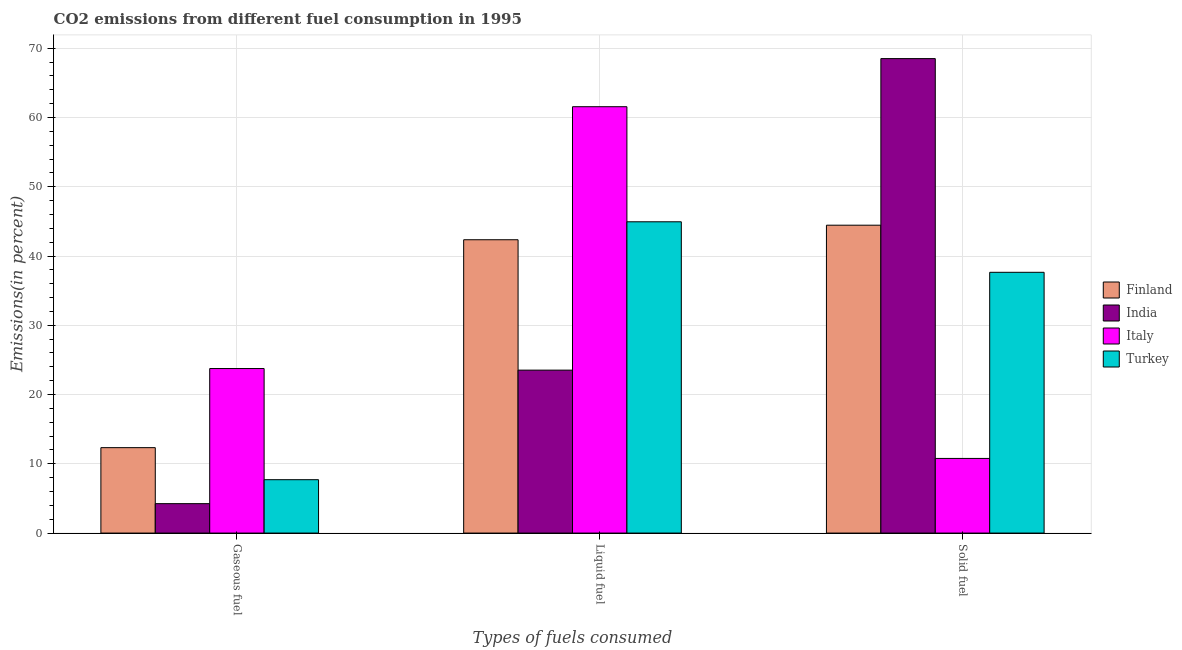How many different coloured bars are there?
Give a very brief answer. 4. How many groups of bars are there?
Your answer should be compact. 3. Are the number of bars on each tick of the X-axis equal?
Provide a succinct answer. Yes. How many bars are there on the 1st tick from the left?
Your answer should be very brief. 4. How many bars are there on the 3rd tick from the right?
Your answer should be very brief. 4. What is the label of the 1st group of bars from the left?
Offer a terse response. Gaseous fuel. What is the percentage of solid fuel emission in India?
Make the answer very short. 68.51. Across all countries, what is the maximum percentage of solid fuel emission?
Make the answer very short. 68.51. Across all countries, what is the minimum percentage of gaseous fuel emission?
Provide a short and direct response. 4.25. In which country was the percentage of solid fuel emission maximum?
Your answer should be compact. India. In which country was the percentage of liquid fuel emission minimum?
Offer a terse response. India. What is the total percentage of solid fuel emission in the graph?
Keep it short and to the point. 161.39. What is the difference between the percentage of liquid fuel emission in Italy and that in Finland?
Make the answer very short. 19.21. What is the difference between the percentage of liquid fuel emission in Italy and the percentage of gaseous fuel emission in Turkey?
Provide a short and direct response. 53.85. What is the average percentage of solid fuel emission per country?
Give a very brief answer. 40.35. What is the difference between the percentage of solid fuel emission and percentage of gaseous fuel emission in Finland?
Offer a very short reply. 32.12. What is the ratio of the percentage of solid fuel emission in India to that in Turkey?
Offer a terse response. 1.82. Is the difference between the percentage of liquid fuel emission in Italy and Turkey greater than the difference between the percentage of solid fuel emission in Italy and Turkey?
Provide a succinct answer. Yes. What is the difference between the highest and the second highest percentage of liquid fuel emission?
Your answer should be compact. 16.62. What is the difference between the highest and the lowest percentage of liquid fuel emission?
Your response must be concise. 38.03. What does the 2nd bar from the right in Gaseous fuel represents?
Ensure brevity in your answer.  Italy. Are all the bars in the graph horizontal?
Your response must be concise. No. Are the values on the major ticks of Y-axis written in scientific E-notation?
Ensure brevity in your answer.  No. Does the graph contain grids?
Ensure brevity in your answer.  Yes. Where does the legend appear in the graph?
Your response must be concise. Center right. How many legend labels are there?
Offer a very short reply. 4. How are the legend labels stacked?
Your response must be concise. Vertical. What is the title of the graph?
Provide a short and direct response. CO2 emissions from different fuel consumption in 1995. What is the label or title of the X-axis?
Your response must be concise. Types of fuels consumed. What is the label or title of the Y-axis?
Your answer should be compact. Emissions(in percent). What is the Emissions(in percent) in Finland in Gaseous fuel?
Provide a succinct answer. 12.33. What is the Emissions(in percent) in India in Gaseous fuel?
Your answer should be very brief. 4.25. What is the Emissions(in percent) of Italy in Gaseous fuel?
Make the answer very short. 23.76. What is the Emissions(in percent) of Turkey in Gaseous fuel?
Your answer should be very brief. 7.71. What is the Emissions(in percent) in Finland in Liquid fuel?
Make the answer very short. 42.35. What is the Emissions(in percent) of India in Liquid fuel?
Provide a short and direct response. 23.53. What is the Emissions(in percent) of Italy in Liquid fuel?
Offer a terse response. 61.56. What is the Emissions(in percent) in Turkey in Liquid fuel?
Keep it short and to the point. 44.94. What is the Emissions(in percent) in Finland in Solid fuel?
Provide a succinct answer. 44.45. What is the Emissions(in percent) in India in Solid fuel?
Your response must be concise. 68.51. What is the Emissions(in percent) in Italy in Solid fuel?
Offer a terse response. 10.78. What is the Emissions(in percent) in Turkey in Solid fuel?
Your response must be concise. 37.65. Across all Types of fuels consumed, what is the maximum Emissions(in percent) in Finland?
Provide a short and direct response. 44.45. Across all Types of fuels consumed, what is the maximum Emissions(in percent) of India?
Your answer should be very brief. 68.51. Across all Types of fuels consumed, what is the maximum Emissions(in percent) of Italy?
Your answer should be very brief. 61.56. Across all Types of fuels consumed, what is the maximum Emissions(in percent) in Turkey?
Give a very brief answer. 44.94. Across all Types of fuels consumed, what is the minimum Emissions(in percent) of Finland?
Your answer should be compact. 12.33. Across all Types of fuels consumed, what is the minimum Emissions(in percent) in India?
Give a very brief answer. 4.25. Across all Types of fuels consumed, what is the minimum Emissions(in percent) in Italy?
Provide a succinct answer. 10.78. Across all Types of fuels consumed, what is the minimum Emissions(in percent) of Turkey?
Keep it short and to the point. 7.71. What is the total Emissions(in percent) in Finland in the graph?
Give a very brief answer. 99.14. What is the total Emissions(in percent) of India in the graph?
Provide a short and direct response. 96.28. What is the total Emissions(in percent) in Italy in the graph?
Give a very brief answer. 96.09. What is the total Emissions(in percent) in Turkey in the graph?
Your response must be concise. 90.3. What is the difference between the Emissions(in percent) in Finland in Gaseous fuel and that in Liquid fuel?
Provide a succinct answer. -30.02. What is the difference between the Emissions(in percent) of India in Gaseous fuel and that in Liquid fuel?
Offer a very short reply. -19.28. What is the difference between the Emissions(in percent) in Italy in Gaseous fuel and that in Liquid fuel?
Your response must be concise. -37.8. What is the difference between the Emissions(in percent) of Turkey in Gaseous fuel and that in Liquid fuel?
Ensure brevity in your answer.  -37.24. What is the difference between the Emissions(in percent) in Finland in Gaseous fuel and that in Solid fuel?
Your response must be concise. -32.12. What is the difference between the Emissions(in percent) of India in Gaseous fuel and that in Solid fuel?
Ensure brevity in your answer.  -64.26. What is the difference between the Emissions(in percent) in Italy in Gaseous fuel and that in Solid fuel?
Keep it short and to the point. 12.98. What is the difference between the Emissions(in percent) of Turkey in Gaseous fuel and that in Solid fuel?
Your response must be concise. -29.95. What is the difference between the Emissions(in percent) in Finland in Liquid fuel and that in Solid fuel?
Your response must be concise. -2.1. What is the difference between the Emissions(in percent) in India in Liquid fuel and that in Solid fuel?
Your response must be concise. -44.98. What is the difference between the Emissions(in percent) in Italy in Liquid fuel and that in Solid fuel?
Your response must be concise. 50.78. What is the difference between the Emissions(in percent) in Turkey in Liquid fuel and that in Solid fuel?
Make the answer very short. 7.29. What is the difference between the Emissions(in percent) in Finland in Gaseous fuel and the Emissions(in percent) in India in Liquid fuel?
Ensure brevity in your answer.  -11.19. What is the difference between the Emissions(in percent) of Finland in Gaseous fuel and the Emissions(in percent) of Italy in Liquid fuel?
Provide a succinct answer. -49.23. What is the difference between the Emissions(in percent) in Finland in Gaseous fuel and the Emissions(in percent) in Turkey in Liquid fuel?
Ensure brevity in your answer.  -32.61. What is the difference between the Emissions(in percent) in India in Gaseous fuel and the Emissions(in percent) in Italy in Liquid fuel?
Keep it short and to the point. -57.31. What is the difference between the Emissions(in percent) of India in Gaseous fuel and the Emissions(in percent) of Turkey in Liquid fuel?
Give a very brief answer. -40.7. What is the difference between the Emissions(in percent) of Italy in Gaseous fuel and the Emissions(in percent) of Turkey in Liquid fuel?
Make the answer very short. -21.19. What is the difference between the Emissions(in percent) of Finland in Gaseous fuel and the Emissions(in percent) of India in Solid fuel?
Make the answer very short. -56.17. What is the difference between the Emissions(in percent) of Finland in Gaseous fuel and the Emissions(in percent) of Italy in Solid fuel?
Your answer should be compact. 1.56. What is the difference between the Emissions(in percent) in Finland in Gaseous fuel and the Emissions(in percent) in Turkey in Solid fuel?
Provide a succinct answer. -25.32. What is the difference between the Emissions(in percent) of India in Gaseous fuel and the Emissions(in percent) of Italy in Solid fuel?
Offer a very short reply. -6.53. What is the difference between the Emissions(in percent) of India in Gaseous fuel and the Emissions(in percent) of Turkey in Solid fuel?
Give a very brief answer. -33.4. What is the difference between the Emissions(in percent) in Italy in Gaseous fuel and the Emissions(in percent) in Turkey in Solid fuel?
Offer a very short reply. -13.9. What is the difference between the Emissions(in percent) in Finland in Liquid fuel and the Emissions(in percent) in India in Solid fuel?
Your response must be concise. -26.16. What is the difference between the Emissions(in percent) in Finland in Liquid fuel and the Emissions(in percent) in Italy in Solid fuel?
Make the answer very short. 31.57. What is the difference between the Emissions(in percent) in Finland in Liquid fuel and the Emissions(in percent) in Turkey in Solid fuel?
Ensure brevity in your answer.  4.7. What is the difference between the Emissions(in percent) of India in Liquid fuel and the Emissions(in percent) of Italy in Solid fuel?
Ensure brevity in your answer.  12.75. What is the difference between the Emissions(in percent) of India in Liquid fuel and the Emissions(in percent) of Turkey in Solid fuel?
Your response must be concise. -14.12. What is the difference between the Emissions(in percent) in Italy in Liquid fuel and the Emissions(in percent) in Turkey in Solid fuel?
Make the answer very short. 23.91. What is the average Emissions(in percent) in Finland per Types of fuels consumed?
Keep it short and to the point. 33.05. What is the average Emissions(in percent) in India per Types of fuels consumed?
Your answer should be very brief. 32.09. What is the average Emissions(in percent) in Italy per Types of fuels consumed?
Ensure brevity in your answer.  32.03. What is the average Emissions(in percent) in Turkey per Types of fuels consumed?
Offer a very short reply. 30.1. What is the difference between the Emissions(in percent) in Finland and Emissions(in percent) in India in Gaseous fuel?
Give a very brief answer. 8.09. What is the difference between the Emissions(in percent) in Finland and Emissions(in percent) in Italy in Gaseous fuel?
Your answer should be compact. -11.42. What is the difference between the Emissions(in percent) of Finland and Emissions(in percent) of Turkey in Gaseous fuel?
Your answer should be compact. 4.63. What is the difference between the Emissions(in percent) of India and Emissions(in percent) of Italy in Gaseous fuel?
Offer a very short reply. -19.51. What is the difference between the Emissions(in percent) in India and Emissions(in percent) in Turkey in Gaseous fuel?
Ensure brevity in your answer.  -3.46. What is the difference between the Emissions(in percent) in Italy and Emissions(in percent) in Turkey in Gaseous fuel?
Offer a very short reply. 16.05. What is the difference between the Emissions(in percent) of Finland and Emissions(in percent) of India in Liquid fuel?
Make the answer very short. 18.82. What is the difference between the Emissions(in percent) of Finland and Emissions(in percent) of Italy in Liquid fuel?
Provide a succinct answer. -19.21. What is the difference between the Emissions(in percent) of Finland and Emissions(in percent) of Turkey in Liquid fuel?
Offer a terse response. -2.59. What is the difference between the Emissions(in percent) in India and Emissions(in percent) in Italy in Liquid fuel?
Provide a short and direct response. -38.03. What is the difference between the Emissions(in percent) of India and Emissions(in percent) of Turkey in Liquid fuel?
Make the answer very short. -21.42. What is the difference between the Emissions(in percent) in Italy and Emissions(in percent) in Turkey in Liquid fuel?
Your answer should be compact. 16.62. What is the difference between the Emissions(in percent) of Finland and Emissions(in percent) of India in Solid fuel?
Offer a terse response. -24.05. What is the difference between the Emissions(in percent) in Finland and Emissions(in percent) in Italy in Solid fuel?
Keep it short and to the point. 33.67. What is the difference between the Emissions(in percent) in Finland and Emissions(in percent) in Turkey in Solid fuel?
Provide a succinct answer. 6.8. What is the difference between the Emissions(in percent) of India and Emissions(in percent) of Italy in Solid fuel?
Offer a terse response. 57.73. What is the difference between the Emissions(in percent) of India and Emissions(in percent) of Turkey in Solid fuel?
Keep it short and to the point. 30.85. What is the difference between the Emissions(in percent) of Italy and Emissions(in percent) of Turkey in Solid fuel?
Ensure brevity in your answer.  -26.87. What is the ratio of the Emissions(in percent) of Finland in Gaseous fuel to that in Liquid fuel?
Offer a very short reply. 0.29. What is the ratio of the Emissions(in percent) in India in Gaseous fuel to that in Liquid fuel?
Ensure brevity in your answer.  0.18. What is the ratio of the Emissions(in percent) of Italy in Gaseous fuel to that in Liquid fuel?
Your answer should be compact. 0.39. What is the ratio of the Emissions(in percent) of Turkey in Gaseous fuel to that in Liquid fuel?
Offer a terse response. 0.17. What is the ratio of the Emissions(in percent) in Finland in Gaseous fuel to that in Solid fuel?
Provide a succinct answer. 0.28. What is the ratio of the Emissions(in percent) in India in Gaseous fuel to that in Solid fuel?
Offer a terse response. 0.06. What is the ratio of the Emissions(in percent) of Italy in Gaseous fuel to that in Solid fuel?
Keep it short and to the point. 2.2. What is the ratio of the Emissions(in percent) of Turkey in Gaseous fuel to that in Solid fuel?
Offer a terse response. 0.2. What is the ratio of the Emissions(in percent) of Finland in Liquid fuel to that in Solid fuel?
Make the answer very short. 0.95. What is the ratio of the Emissions(in percent) in India in Liquid fuel to that in Solid fuel?
Offer a terse response. 0.34. What is the ratio of the Emissions(in percent) of Italy in Liquid fuel to that in Solid fuel?
Your answer should be compact. 5.71. What is the ratio of the Emissions(in percent) in Turkey in Liquid fuel to that in Solid fuel?
Ensure brevity in your answer.  1.19. What is the difference between the highest and the second highest Emissions(in percent) in Finland?
Offer a terse response. 2.1. What is the difference between the highest and the second highest Emissions(in percent) in India?
Your answer should be compact. 44.98. What is the difference between the highest and the second highest Emissions(in percent) of Italy?
Keep it short and to the point. 37.8. What is the difference between the highest and the second highest Emissions(in percent) of Turkey?
Offer a very short reply. 7.29. What is the difference between the highest and the lowest Emissions(in percent) in Finland?
Make the answer very short. 32.12. What is the difference between the highest and the lowest Emissions(in percent) of India?
Make the answer very short. 64.26. What is the difference between the highest and the lowest Emissions(in percent) in Italy?
Provide a short and direct response. 50.78. What is the difference between the highest and the lowest Emissions(in percent) of Turkey?
Ensure brevity in your answer.  37.24. 